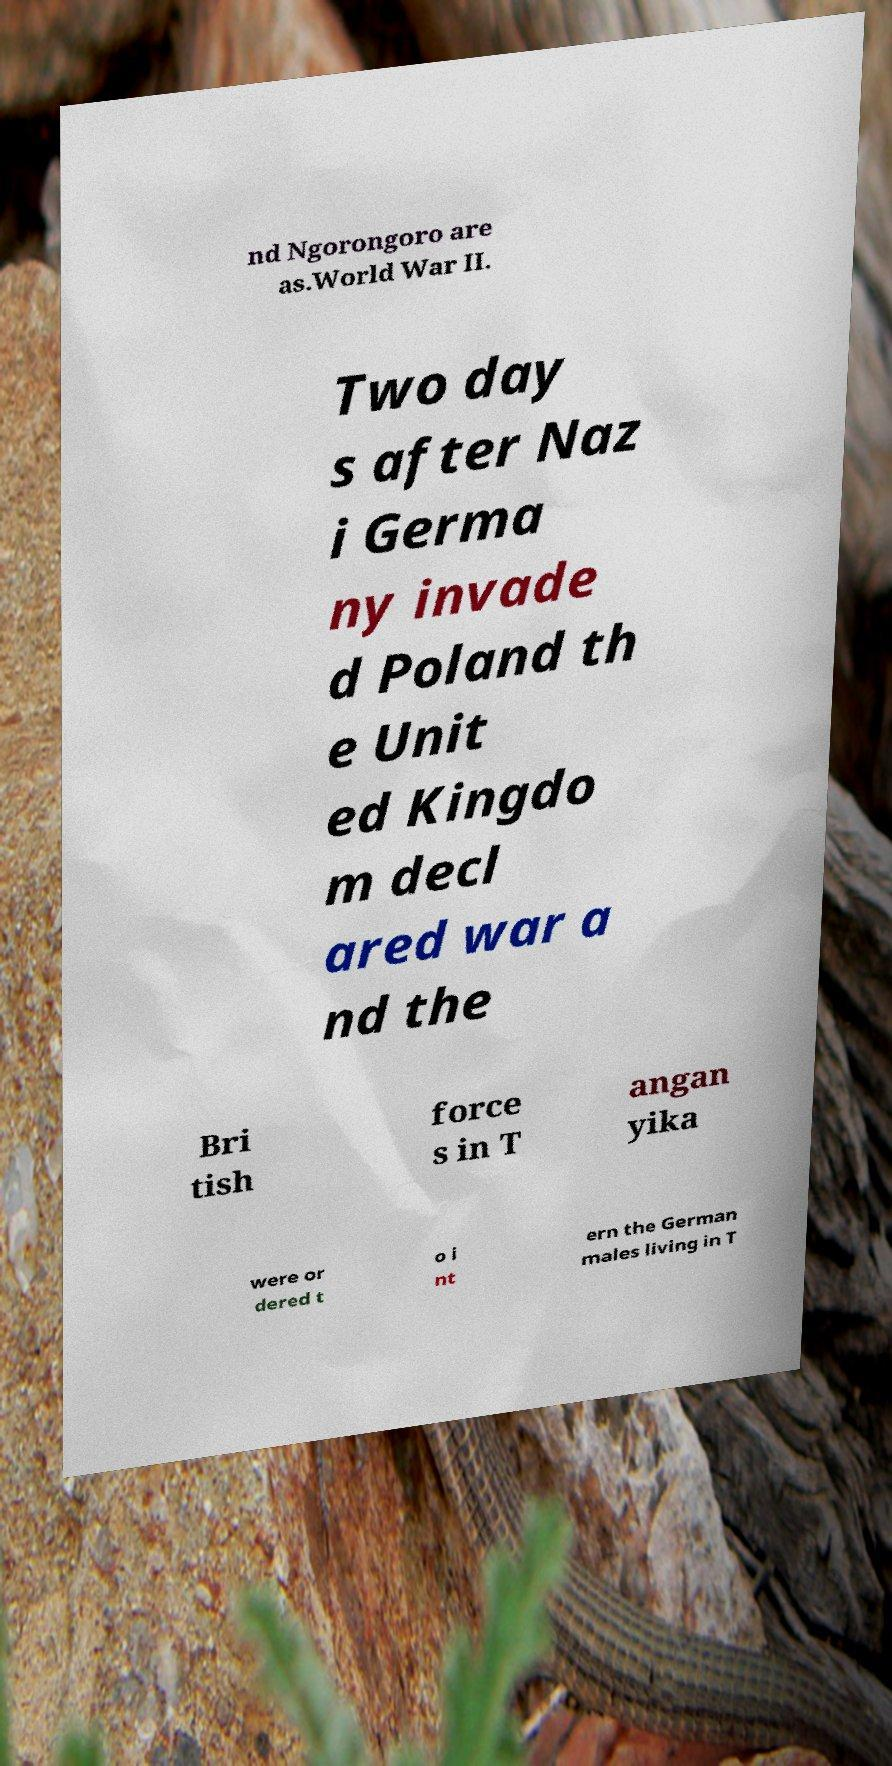I need the written content from this picture converted into text. Can you do that? nd Ngorongoro are as.World War II. Two day s after Naz i Germa ny invade d Poland th e Unit ed Kingdo m decl ared war a nd the Bri tish force s in T angan yika were or dered t o i nt ern the German males living in T 